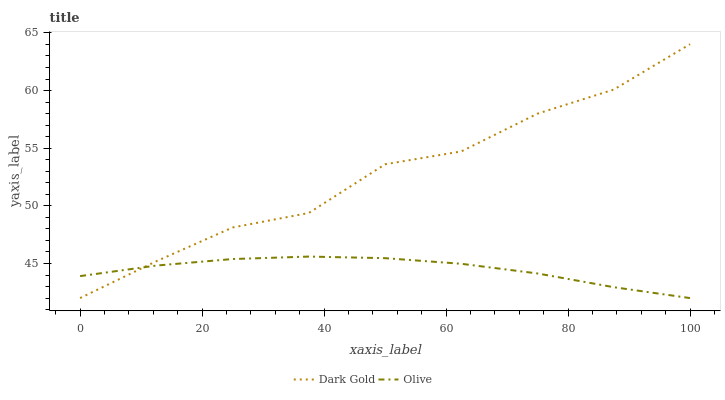Does Olive have the minimum area under the curve?
Answer yes or no. Yes. Does Dark Gold have the maximum area under the curve?
Answer yes or no. Yes. Does Dark Gold have the minimum area under the curve?
Answer yes or no. No. Is Olive the smoothest?
Answer yes or no. Yes. Is Dark Gold the roughest?
Answer yes or no. Yes. Is Dark Gold the smoothest?
Answer yes or no. No. Does Olive have the lowest value?
Answer yes or no. Yes. Does Dark Gold have the highest value?
Answer yes or no. Yes. Does Dark Gold intersect Olive?
Answer yes or no. Yes. Is Dark Gold less than Olive?
Answer yes or no. No. Is Dark Gold greater than Olive?
Answer yes or no. No. 